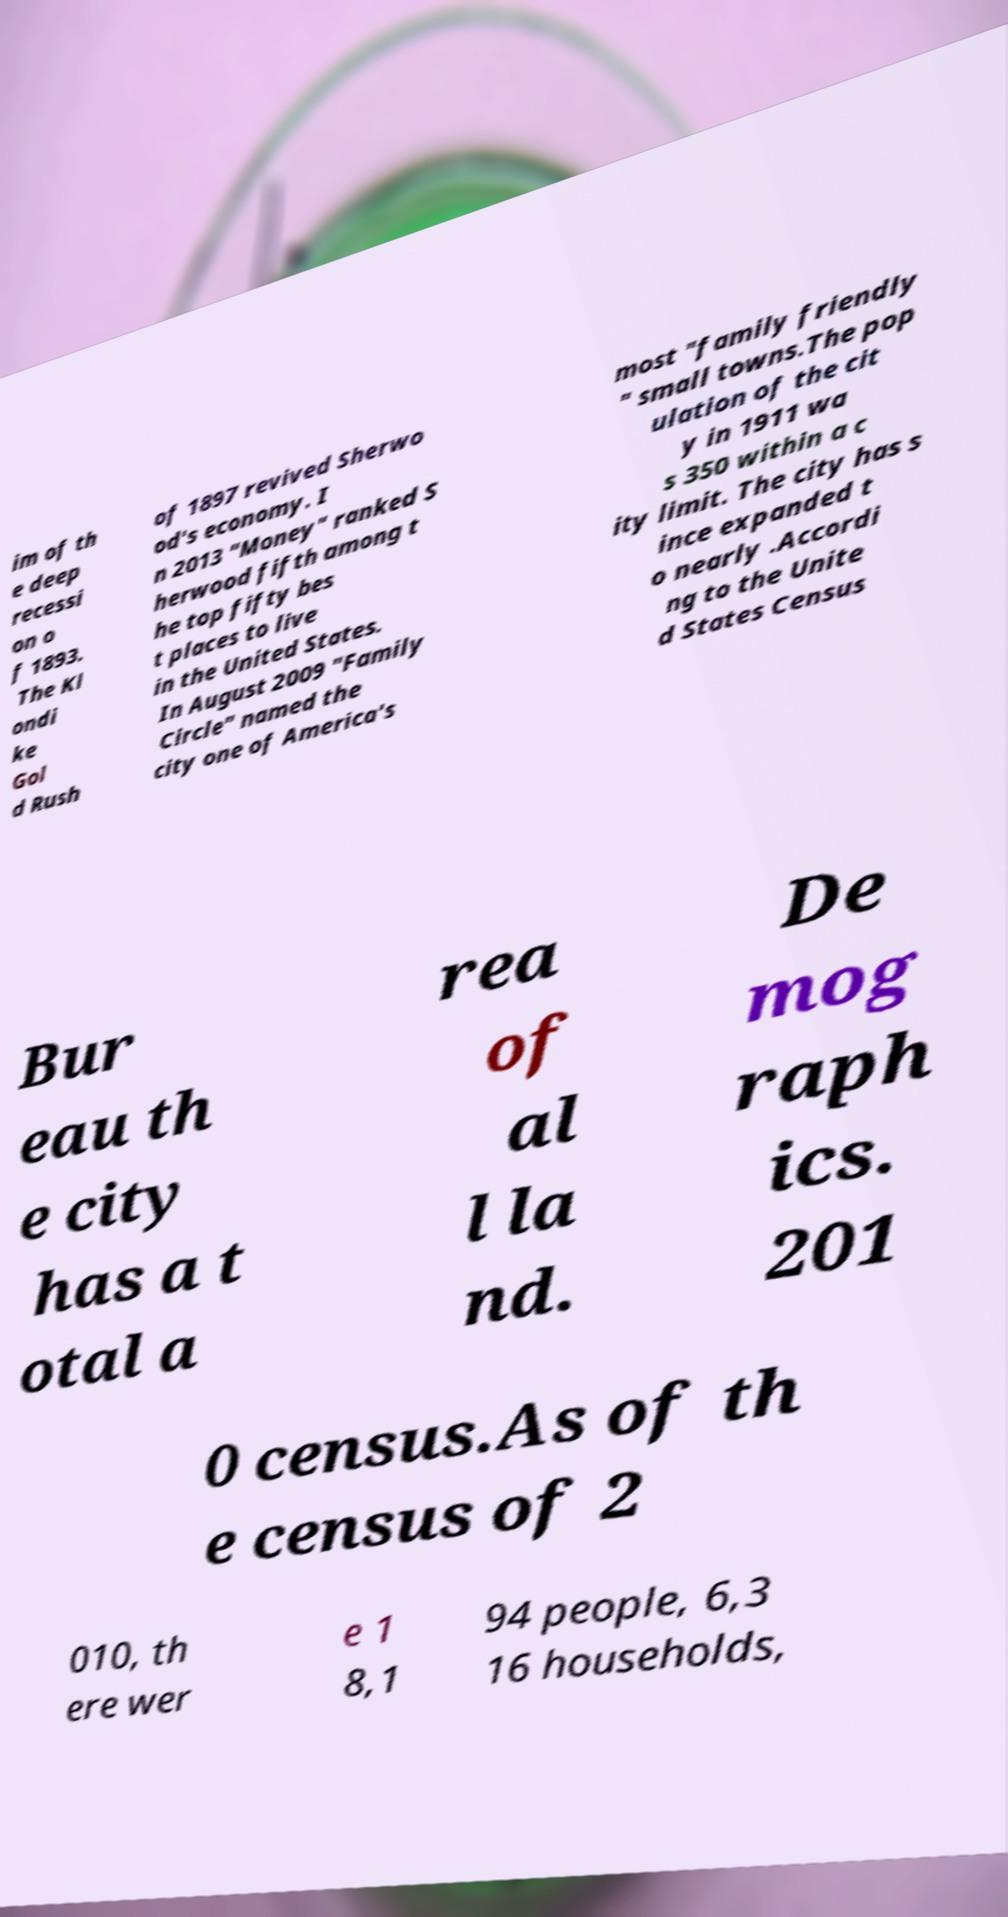Please identify and transcribe the text found in this image. im of th e deep recessi on o f 1893. The Kl ondi ke Gol d Rush of 1897 revived Sherwo od's economy. I n 2013 "Money" ranked S herwood fifth among t he top fifty bes t places to live in the United States. In August 2009 "Family Circle" named the city one of America's most "family friendly " small towns.The pop ulation of the cit y in 1911 wa s 350 within a c ity limit. The city has s ince expanded t o nearly .Accordi ng to the Unite d States Census Bur eau th e city has a t otal a rea of al l la nd. De mog raph ics. 201 0 census.As of th e census of 2 010, th ere wer e 1 8,1 94 people, 6,3 16 households, 